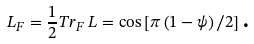Convert formula to latex. <formula><loc_0><loc_0><loc_500><loc_500>L _ { F } = \frac { 1 } { 2 } T r _ { F } \, L = \cos \left [ \pi \left ( 1 - \psi \right ) / 2 \right ] \text {.}</formula> 